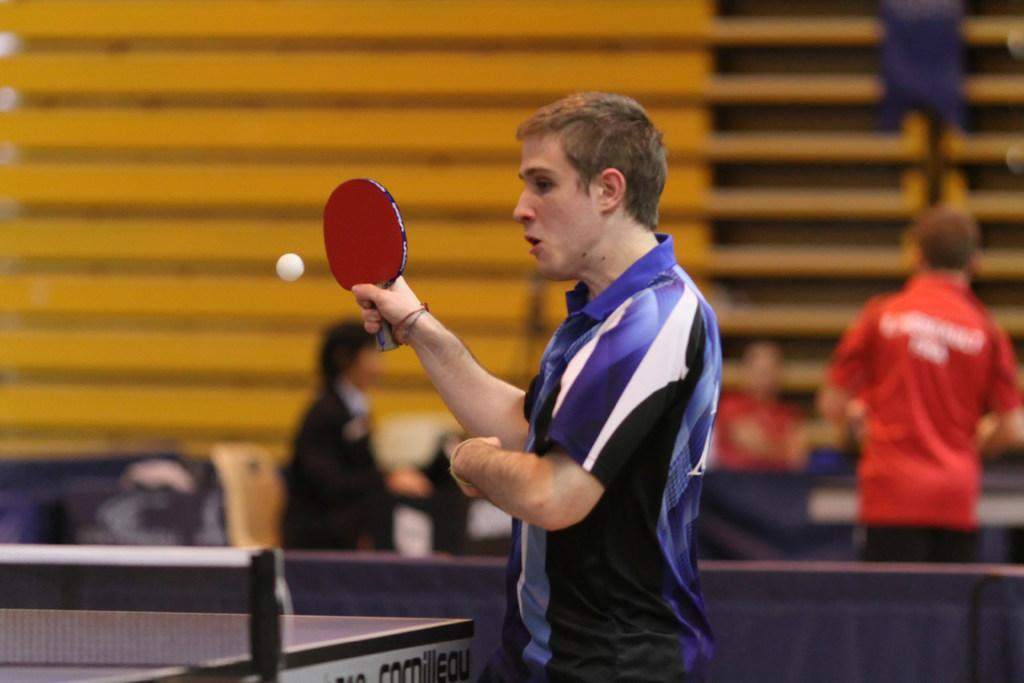Who is in the image? There is a person in the image. What is the person wearing? The person is wearing a blue T-shirt. What is the person holding in the image? The person is holding a table tennis racket. What can be seen in the background of the image? There is a table tennis court in the image. What other table tennis-related item is present in the image? There is a table tennis ball in the image. What type of credit card is the person using in the image? There is no credit card present in the image; it features a person holding a table tennis racket and standing on a table tennis court. 